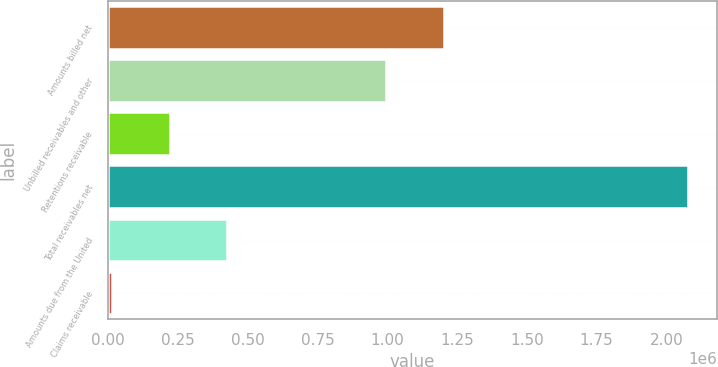Convert chart to OTSL. <chart><loc_0><loc_0><loc_500><loc_500><bar_chart><fcel>Amounts billed net<fcel>Unbilled receivables and other<fcel>Retentions receivable<fcel>Total receivables net<fcel>Amounts due from the United<fcel>Claims receivable<nl><fcel>1.20279e+06<fcel>996516<fcel>220990<fcel>2.07749e+06<fcel>427268<fcel>14712<nl></chart> 